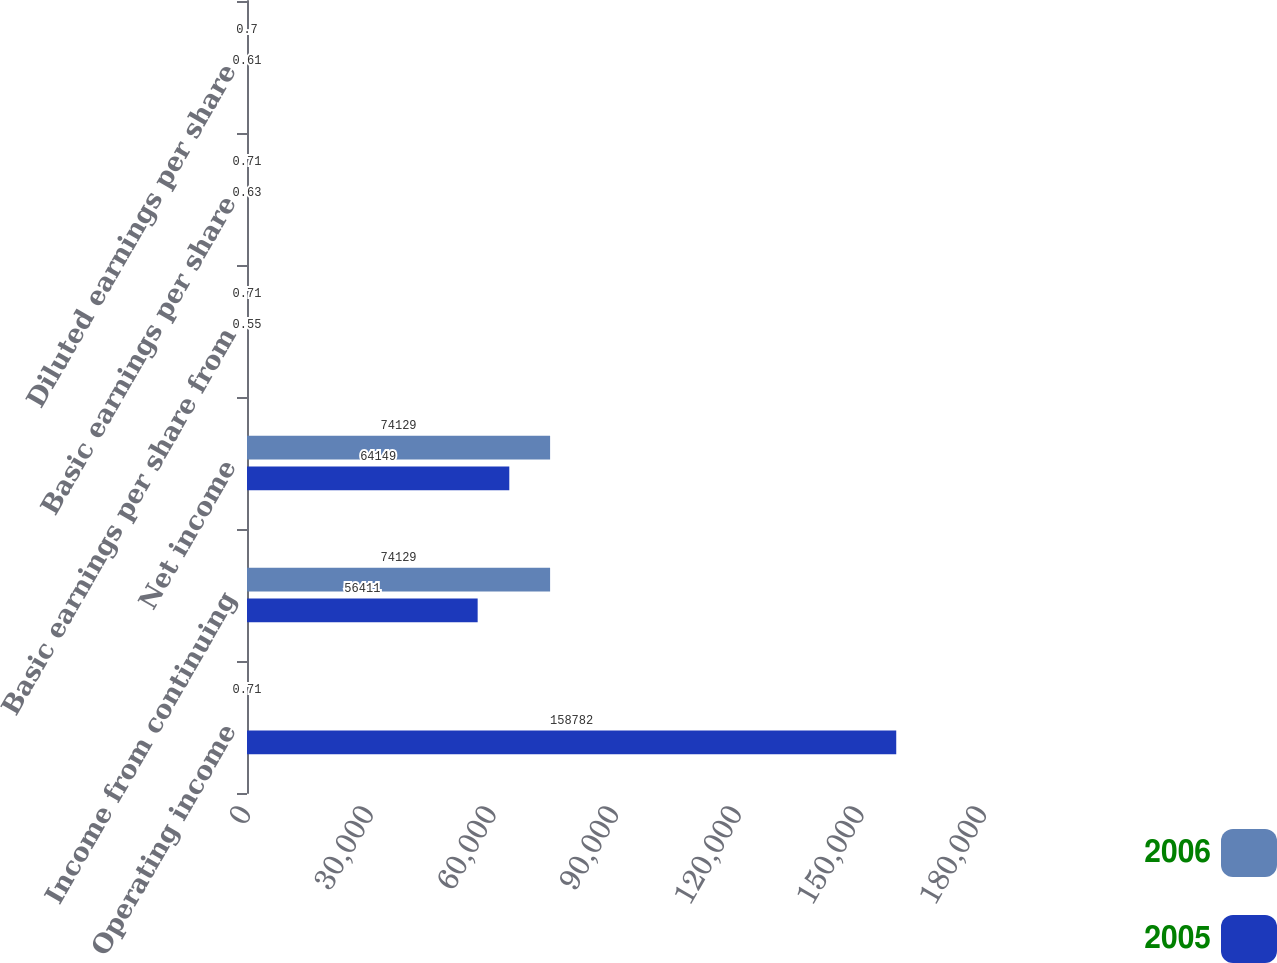Convert chart. <chart><loc_0><loc_0><loc_500><loc_500><stacked_bar_chart><ecel><fcel>Operating income<fcel>Income from continuing<fcel>Net income<fcel>Basic earnings per share from<fcel>Basic earnings per share<fcel>Diluted earnings per share<nl><fcel>2006<fcel>0.71<fcel>74129<fcel>74129<fcel>0.71<fcel>0.71<fcel>0.7<nl><fcel>2005<fcel>158782<fcel>56411<fcel>64149<fcel>0.55<fcel>0.63<fcel>0.61<nl></chart> 